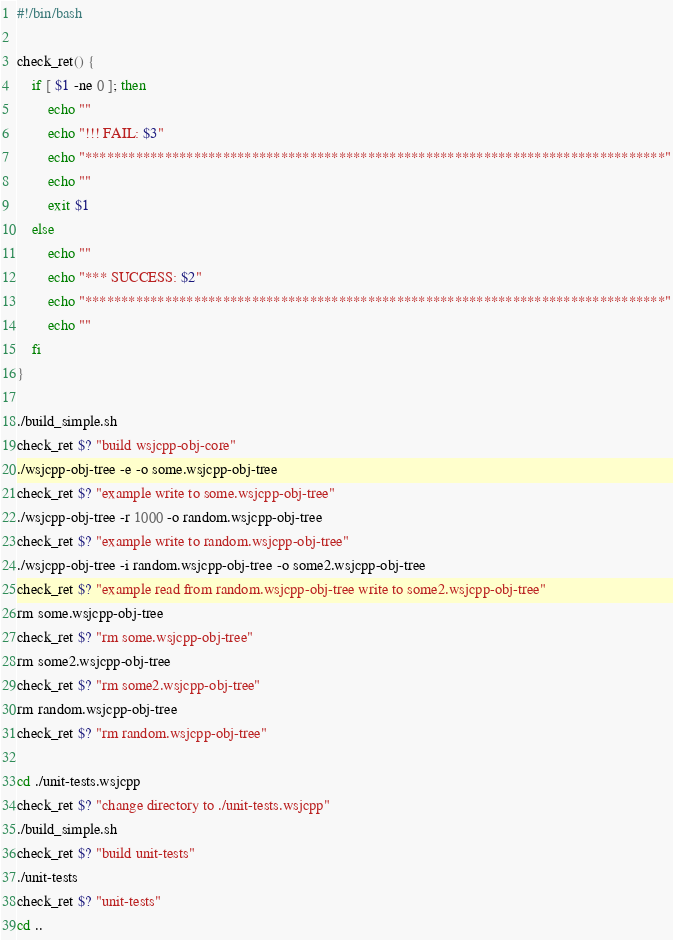Convert code to text. <code><loc_0><loc_0><loc_500><loc_500><_Bash_>#!/bin/bash

check_ret() {
    if [ $1 -ne 0 ]; then
        echo ""
        echo "!!! FAIL: $3"
        echo "********************************************************************************"
        echo ""
        exit $1
    else
        echo ""
        echo "*** SUCCESS: $2"
        echo "********************************************************************************"
        echo ""
    fi
} 

./build_simple.sh
check_ret $? "build wsjcpp-obj-core"
./wsjcpp-obj-tree -e -o some.wsjcpp-obj-tree
check_ret $? "example write to some.wsjcpp-obj-tree"
./wsjcpp-obj-tree -r 1000 -o random.wsjcpp-obj-tree
check_ret $? "example write to random.wsjcpp-obj-tree"
./wsjcpp-obj-tree -i random.wsjcpp-obj-tree -o some2.wsjcpp-obj-tree
check_ret $? "example read from random.wsjcpp-obj-tree write to some2.wsjcpp-obj-tree"
rm some.wsjcpp-obj-tree
check_ret $? "rm some.wsjcpp-obj-tree"
rm some2.wsjcpp-obj-tree
check_ret $? "rm some2.wsjcpp-obj-tree"
rm random.wsjcpp-obj-tree
check_ret $? "rm random.wsjcpp-obj-tree"

cd ./unit-tests.wsjcpp
check_ret $? "change directory to ./unit-tests.wsjcpp"
./build_simple.sh
check_ret $? "build unit-tests"
./unit-tests
check_ret $? "unit-tests"
cd ..</code> 